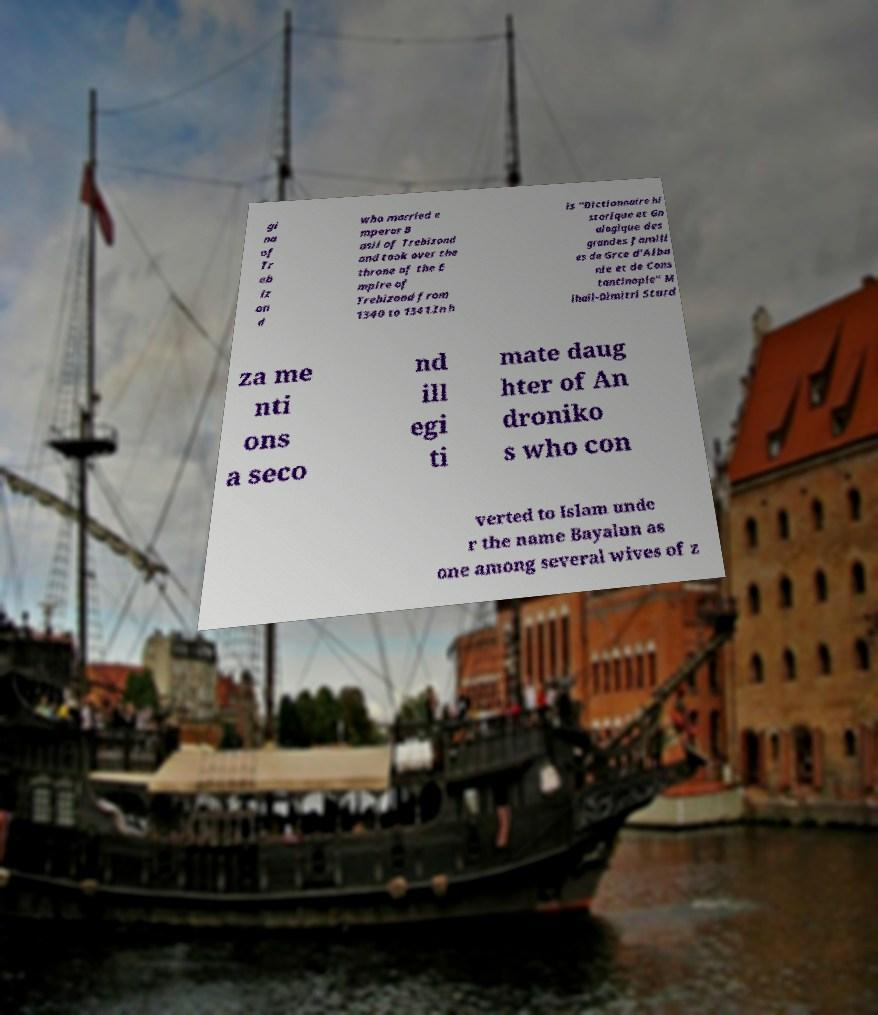Can you accurately transcribe the text from the provided image for me? gi na of Tr eb iz on d who married e mperor B asil of Trebizond and took over the throne of the E mpire of Trebizond from 1340 to 1341.In h is "Dictionnaire hi storique et Gn alogique des grandes famill es de Grce d'Alba nie et de Cons tantinople" M ihail-Dimitri Sturd za me nti ons a seco nd ill egi ti mate daug hter of An droniko s who con verted to Islam unde r the name Bayalun as one among several wives of z 